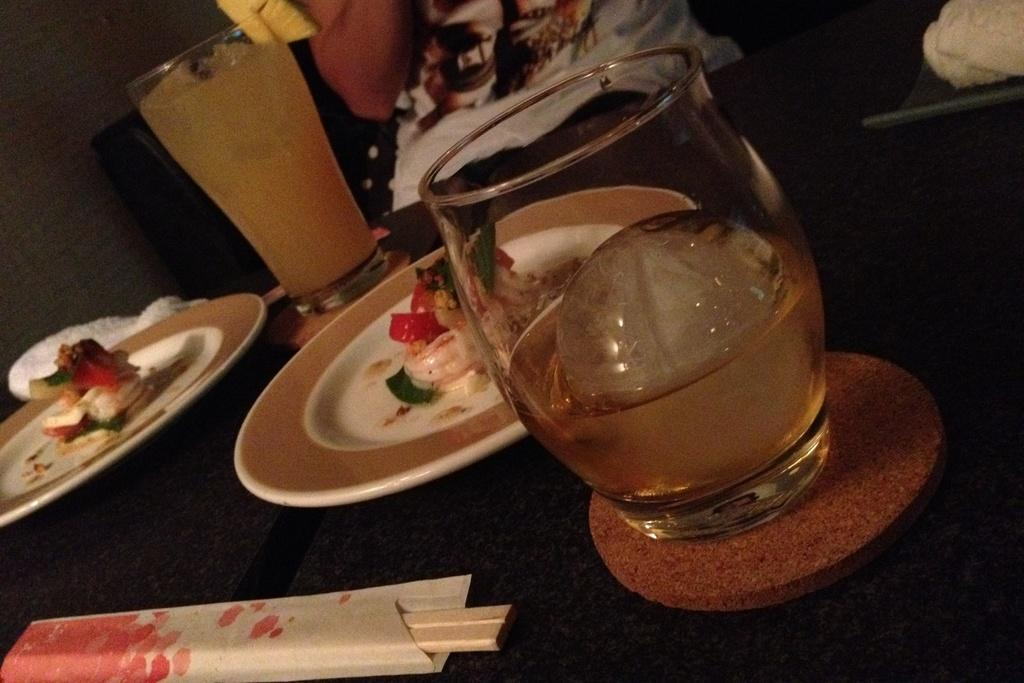What piece of furniture is present in the image? There is a table in the image. What is on the table? There are plates with food and a glass with a drink on the table. What else can be seen on the table? There are sticks on the table. How would you describe the lighting in the image? The background of the image appears dark. Is there any quicksand visible in the image? No, there is no quicksand present in the image. What type of pear is being served on the plates in the image? There are no pears visible in the image; only plates with food are present. 